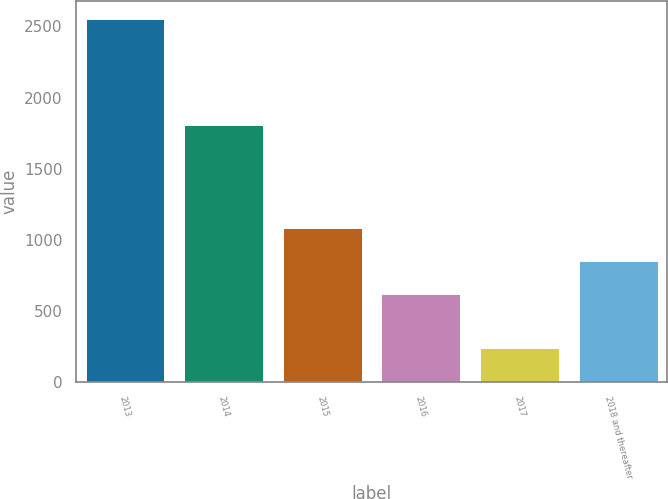<chart> <loc_0><loc_0><loc_500><loc_500><bar_chart><fcel>2013<fcel>2014<fcel>2015<fcel>2016<fcel>2017<fcel>2018 and thereafter<nl><fcel>2552<fcel>1809<fcel>1081<fcel>618<fcel>237<fcel>849.5<nl></chart> 